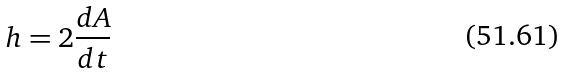<formula> <loc_0><loc_0><loc_500><loc_500>h = 2 \frac { d A } { d t }</formula> 